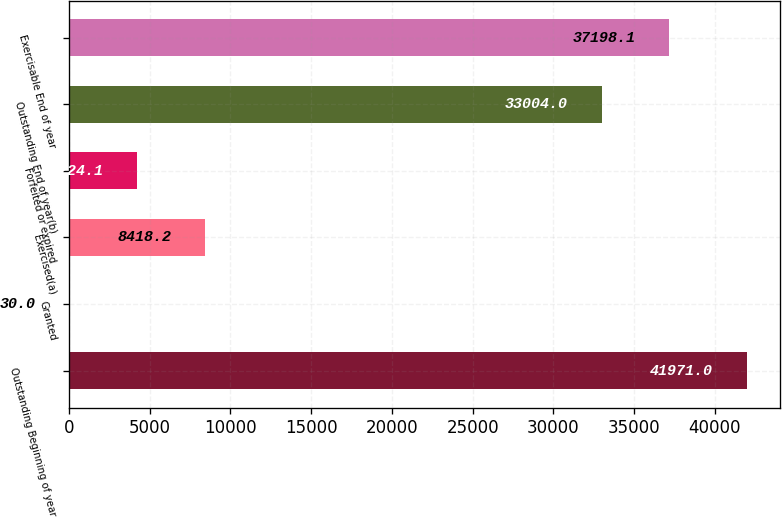Convert chart to OTSL. <chart><loc_0><loc_0><loc_500><loc_500><bar_chart><fcel>Outstanding Beginning of year<fcel>Granted<fcel>Exercised(a)<fcel>Forfeited or expired<fcel>Outstanding End of year(b)<fcel>Exercisable End of year<nl><fcel>41971<fcel>30<fcel>8418.2<fcel>4224.1<fcel>33004<fcel>37198.1<nl></chart> 